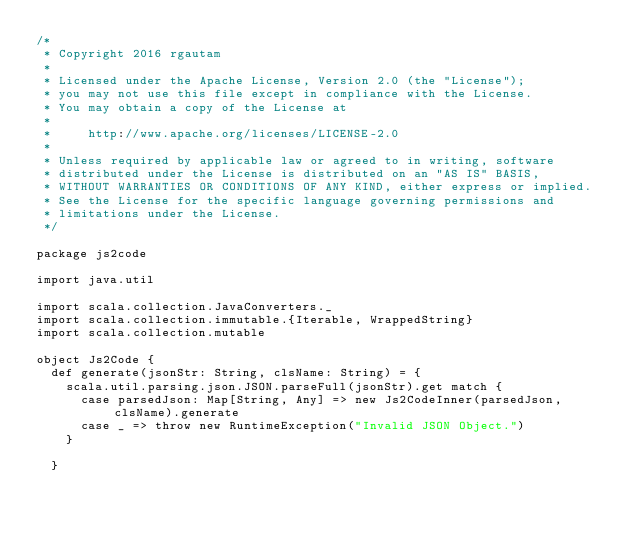Convert code to text. <code><loc_0><loc_0><loc_500><loc_500><_Scala_>/*
 * Copyright 2016 rgautam
 *
 * Licensed under the Apache License, Version 2.0 (the "License");
 * you may not use this file except in compliance with the License.
 * You may obtain a copy of the License at
 *
 *     http://www.apache.org/licenses/LICENSE-2.0
 *
 * Unless required by applicable law or agreed to in writing, software
 * distributed under the License is distributed on an "AS IS" BASIS,
 * WITHOUT WARRANTIES OR CONDITIONS OF ANY KIND, either express or implied.
 * See the License for the specific language governing permissions and
 * limitations under the License.
 */

package js2code

import java.util

import scala.collection.JavaConverters._
import scala.collection.immutable.{Iterable, WrappedString}
import scala.collection.mutable

object Js2Code {
  def generate(jsonStr: String, clsName: String) = {
    scala.util.parsing.json.JSON.parseFull(jsonStr).get match {
      case parsedJson: Map[String, Any] => new Js2CodeInner(parsedJson, clsName).generate
      case _ => throw new RuntimeException("Invalid JSON Object.")
    }

  }
</code> 